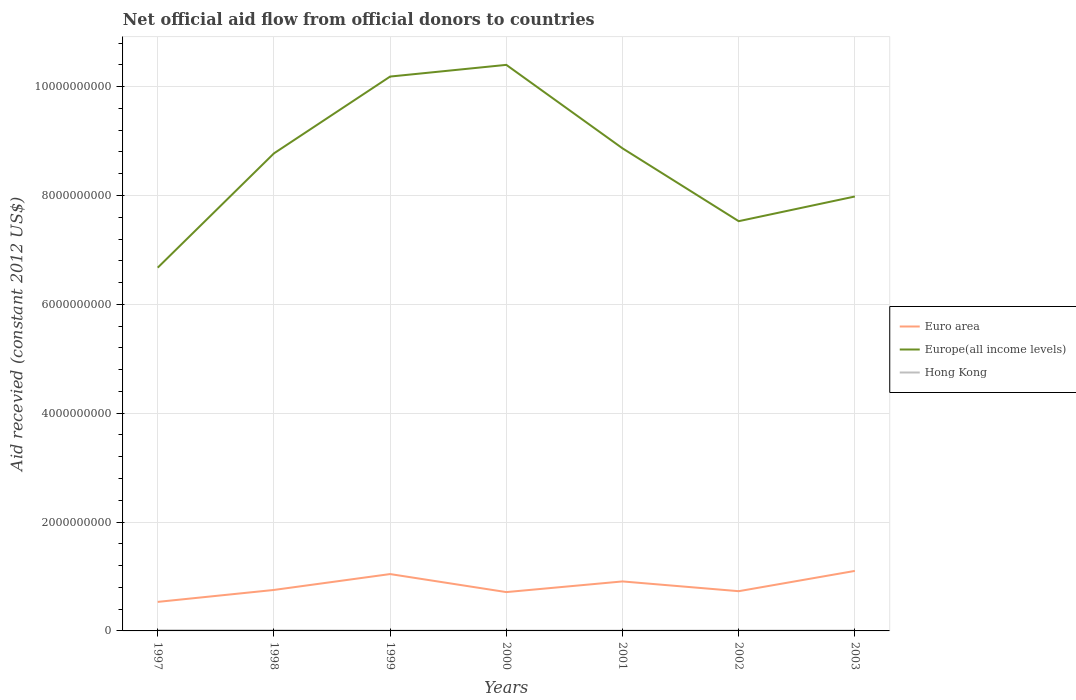How many different coloured lines are there?
Provide a short and direct response. 3. Across all years, what is the maximum total aid received in Europe(all income levels)?
Ensure brevity in your answer.  6.67e+09. In which year was the total aid received in Euro area maximum?
Offer a terse response. 1997. What is the total total aid received in Euro area in the graph?
Your answer should be compact. -1.57e+08. What is the difference between the highest and the second highest total aid received in Europe(all income levels)?
Make the answer very short. 3.73e+09. Is the total aid received in Europe(all income levels) strictly greater than the total aid received in Hong Kong over the years?
Your response must be concise. No. How many lines are there?
Provide a short and direct response. 3. How many years are there in the graph?
Provide a short and direct response. 7. Does the graph contain any zero values?
Keep it short and to the point. No. Does the graph contain grids?
Your answer should be compact. Yes. Where does the legend appear in the graph?
Offer a terse response. Center right. What is the title of the graph?
Give a very brief answer. Net official aid flow from official donors to countries. Does "Switzerland" appear as one of the legend labels in the graph?
Ensure brevity in your answer.  No. What is the label or title of the X-axis?
Your answer should be very brief. Years. What is the label or title of the Y-axis?
Provide a short and direct response. Aid recevied (constant 2012 US$). What is the Aid recevied (constant 2012 US$) of Euro area in 1997?
Your response must be concise. 5.33e+08. What is the Aid recevied (constant 2012 US$) of Europe(all income levels) in 1997?
Your response must be concise. 6.67e+09. What is the Aid recevied (constant 2012 US$) in Hong Kong in 1997?
Offer a very short reply. 1.18e+07. What is the Aid recevied (constant 2012 US$) of Euro area in 1998?
Keep it short and to the point. 7.53e+08. What is the Aid recevied (constant 2012 US$) of Europe(all income levels) in 1998?
Offer a very short reply. 8.77e+09. What is the Aid recevied (constant 2012 US$) in Hong Kong in 1998?
Keep it short and to the point. 9.64e+06. What is the Aid recevied (constant 2012 US$) in Euro area in 1999?
Your answer should be compact. 1.04e+09. What is the Aid recevied (constant 2012 US$) of Europe(all income levels) in 1999?
Your answer should be compact. 1.02e+1. What is the Aid recevied (constant 2012 US$) of Hong Kong in 1999?
Your answer should be compact. 4.73e+06. What is the Aid recevied (constant 2012 US$) of Euro area in 2000?
Provide a short and direct response. 7.13e+08. What is the Aid recevied (constant 2012 US$) of Europe(all income levels) in 2000?
Make the answer very short. 1.04e+1. What is the Aid recevied (constant 2012 US$) of Hong Kong in 2000?
Keep it short and to the point. 5.83e+06. What is the Aid recevied (constant 2012 US$) in Euro area in 2001?
Your answer should be very brief. 9.09e+08. What is the Aid recevied (constant 2012 US$) in Europe(all income levels) in 2001?
Your response must be concise. 8.87e+09. What is the Aid recevied (constant 2012 US$) in Hong Kong in 2001?
Provide a short and direct response. 5.12e+06. What is the Aid recevied (constant 2012 US$) in Euro area in 2002?
Keep it short and to the point. 7.30e+08. What is the Aid recevied (constant 2012 US$) in Europe(all income levels) in 2002?
Ensure brevity in your answer.  7.53e+09. What is the Aid recevied (constant 2012 US$) of Hong Kong in 2002?
Give a very brief answer. 5.92e+06. What is the Aid recevied (constant 2012 US$) in Euro area in 2003?
Your response must be concise. 1.10e+09. What is the Aid recevied (constant 2012 US$) in Europe(all income levels) in 2003?
Provide a succinct answer. 7.98e+09. What is the Aid recevied (constant 2012 US$) in Hong Kong in 2003?
Provide a short and direct response. 6.99e+06. Across all years, what is the maximum Aid recevied (constant 2012 US$) in Euro area?
Keep it short and to the point. 1.10e+09. Across all years, what is the maximum Aid recevied (constant 2012 US$) in Europe(all income levels)?
Your response must be concise. 1.04e+1. Across all years, what is the maximum Aid recevied (constant 2012 US$) of Hong Kong?
Make the answer very short. 1.18e+07. Across all years, what is the minimum Aid recevied (constant 2012 US$) of Euro area?
Your answer should be very brief. 5.33e+08. Across all years, what is the minimum Aid recevied (constant 2012 US$) of Europe(all income levels)?
Your response must be concise. 6.67e+09. Across all years, what is the minimum Aid recevied (constant 2012 US$) in Hong Kong?
Make the answer very short. 4.73e+06. What is the total Aid recevied (constant 2012 US$) of Euro area in the graph?
Ensure brevity in your answer.  5.79e+09. What is the total Aid recevied (constant 2012 US$) of Europe(all income levels) in the graph?
Give a very brief answer. 6.04e+1. What is the total Aid recevied (constant 2012 US$) in Hong Kong in the graph?
Offer a terse response. 5.00e+07. What is the difference between the Aid recevied (constant 2012 US$) in Euro area in 1997 and that in 1998?
Your answer should be compact. -2.19e+08. What is the difference between the Aid recevied (constant 2012 US$) of Europe(all income levels) in 1997 and that in 1998?
Make the answer very short. -2.10e+09. What is the difference between the Aid recevied (constant 2012 US$) in Hong Kong in 1997 and that in 1998?
Make the answer very short. 2.16e+06. What is the difference between the Aid recevied (constant 2012 US$) of Euro area in 1997 and that in 1999?
Your answer should be compact. -5.11e+08. What is the difference between the Aid recevied (constant 2012 US$) of Europe(all income levels) in 1997 and that in 1999?
Offer a very short reply. -3.51e+09. What is the difference between the Aid recevied (constant 2012 US$) of Hong Kong in 1997 and that in 1999?
Give a very brief answer. 7.07e+06. What is the difference between the Aid recevied (constant 2012 US$) of Euro area in 1997 and that in 2000?
Give a very brief answer. -1.80e+08. What is the difference between the Aid recevied (constant 2012 US$) of Europe(all income levels) in 1997 and that in 2000?
Your answer should be compact. -3.73e+09. What is the difference between the Aid recevied (constant 2012 US$) in Hong Kong in 1997 and that in 2000?
Keep it short and to the point. 5.97e+06. What is the difference between the Aid recevied (constant 2012 US$) in Euro area in 1997 and that in 2001?
Your response must be concise. -3.76e+08. What is the difference between the Aid recevied (constant 2012 US$) in Europe(all income levels) in 1997 and that in 2001?
Your answer should be compact. -2.19e+09. What is the difference between the Aid recevied (constant 2012 US$) in Hong Kong in 1997 and that in 2001?
Your answer should be compact. 6.68e+06. What is the difference between the Aid recevied (constant 2012 US$) in Euro area in 1997 and that in 2002?
Offer a very short reply. -1.97e+08. What is the difference between the Aid recevied (constant 2012 US$) of Europe(all income levels) in 1997 and that in 2002?
Ensure brevity in your answer.  -8.54e+08. What is the difference between the Aid recevied (constant 2012 US$) of Hong Kong in 1997 and that in 2002?
Ensure brevity in your answer.  5.88e+06. What is the difference between the Aid recevied (constant 2012 US$) in Euro area in 1997 and that in 2003?
Ensure brevity in your answer.  -5.69e+08. What is the difference between the Aid recevied (constant 2012 US$) of Europe(all income levels) in 1997 and that in 2003?
Give a very brief answer. -1.31e+09. What is the difference between the Aid recevied (constant 2012 US$) in Hong Kong in 1997 and that in 2003?
Provide a succinct answer. 4.81e+06. What is the difference between the Aid recevied (constant 2012 US$) in Euro area in 1998 and that in 1999?
Make the answer very short. -2.92e+08. What is the difference between the Aid recevied (constant 2012 US$) of Europe(all income levels) in 1998 and that in 1999?
Your answer should be compact. -1.41e+09. What is the difference between the Aid recevied (constant 2012 US$) of Hong Kong in 1998 and that in 1999?
Your answer should be very brief. 4.91e+06. What is the difference between the Aid recevied (constant 2012 US$) in Euro area in 1998 and that in 2000?
Keep it short and to the point. 3.93e+07. What is the difference between the Aid recevied (constant 2012 US$) in Europe(all income levels) in 1998 and that in 2000?
Give a very brief answer. -1.63e+09. What is the difference between the Aid recevied (constant 2012 US$) in Hong Kong in 1998 and that in 2000?
Offer a terse response. 3.81e+06. What is the difference between the Aid recevied (constant 2012 US$) in Euro area in 1998 and that in 2001?
Ensure brevity in your answer.  -1.57e+08. What is the difference between the Aid recevied (constant 2012 US$) in Europe(all income levels) in 1998 and that in 2001?
Ensure brevity in your answer.  -9.31e+07. What is the difference between the Aid recevied (constant 2012 US$) of Hong Kong in 1998 and that in 2001?
Offer a terse response. 4.52e+06. What is the difference between the Aid recevied (constant 2012 US$) of Euro area in 1998 and that in 2002?
Give a very brief answer. 2.28e+07. What is the difference between the Aid recevied (constant 2012 US$) of Europe(all income levels) in 1998 and that in 2002?
Keep it short and to the point. 1.25e+09. What is the difference between the Aid recevied (constant 2012 US$) in Hong Kong in 1998 and that in 2002?
Offer a very short reply. 3.72e+06. What is the difference between the Aid recevied (constant 2012 US$) of Euro area in 1998 and that in 2003?
Ensure brevity in your answer.  -3.50e+08. What is the difference between the Aid recevied (constant 2012 US$) of Europe(all income levels) in 1998 and that in 2003?
Give a very brief answer. 7.92e+08. What is the difference between the Aid recevied (constant 2012 US$) of Hong Kong in 1998 and that in 2003?
Make the answer very short. 2.65e+06. What is the difference between the Aid recevied (constant 2012 US$) of Euro area in 1999 and that in 2000?
Your answer should be compact. 3.31e+08. What is the difference between the Aid recevied (constant 2012 US$) of Europe(all income levels) in 1999 and that in 2000?
Your answer should be very brief. -2.15e+08. What is the difference between the Aid recevied (constant 2012 US$) in Hong Kong in 1999 and that in 2000?
Keep it short and to the point. -1.10e+06. What is the difference between the Aid recevied (constant 2012 US$) of Euro area in 1999 and that in 2001?
Provide a succinct answer. 1.35e+08. What is the difference between the Aid recevied (constant 2012 US$) of Europe(all income levels) in 1999 and that in 2001?
Offer a very short reply. 1.32e+09. What is the difference between the Aid recevied (constant 2012 US$) of Hong Kong in 1999 and that in 2001?
Make the answer very short. -3.90e+05. What is the difference between the Aid recevied (constant 2012 US$) in Euro area in 1999 and that in 2002?
Make the answer very short. 3.15e+08. What is the difference between the Aid recevied (constant 2012 US$) of Europe(all income levels) in 1999 and that in 2002?
Your response must be concise. 2.66e+09. What is the difference between the Aid recevied (constant 2012 US$) of Hong Kong in 1999 and that in 2002?
Give a very brief answer. -1.19e+06. What is the difference between the Aid recevied (constant 2012 US$) in Euro area in 1999 and that in 2003?
Ensure brevity in your answer.  -5.82e+07. What is the difference between the Aid recevied (constant 2012 US$) in Europe(all income levels) in 1999 and that in 2003?
Your answer should be very brief. 2.20e+09. What is the difference between the Aid recevied (constant 2012 US$) in Hong Kong in 1999 and that in 2003?
Your response must be concise. -2.26e+06. What is the difference between the Aid recevied (constant 2012 US$) in Euro area in 2000 and that in 2001?
Provide a short and direct response. -1.96e+08. What is the difference between the Aid recevied (constant 2012 US$) of Europe(all income levels) in 2000 and that in 2001?
Offer a terse response. 1.53e+09. What is the difference between the Aid recevied (constant 2012 US$) of Hong Kong in 2000 and that in 2001?
Provide a short and direct response. 7.10e+05. What is the difference between the Aid recevied (constant 2012 US$) in Euro area in 2000 and that in 2002?
Offer a very short reply. -1.65e+07. What is the difference between the Aid recevied (constant 2012 US$) of Europe(all income levels) in 2000 and that in 2002?
Give a very brief answer. 2.87e+09. What is the difference between the Aid recevied (constant 2012 US$) of Euro area in 2000 and that in 2003?
Ensure brevity in your answer.  -3.89e+08. What is the difference between the Aid recevied (constant 2012 US$) in Europe(all income levels) in 2000 and that in 2003?
Ensure brevity in your answer.  2.42e+09. What is the difference between the Aid recevied (constant 2012 US$) of Hong Kong in 2000 and that in 2003?
Your answer should be very brief. -1.16e+06. What is the difference between the Aid recevied (constant 2012 US$) of Euro area in 2001 and that in 2002?
Make the answer very short. 1.79e+08. What is the difference between the Aid recevied (constant 2012 US$) in Europe(all income levels) in 2001 and that in 2002?
Ensure brevity in your answer.  1.34e+09. What is the difference between the Aid recevied (constant 2012 US$) in Hong Kong in 2001 and that in 2002?
Provide a succinct answer. -8.00e+05. What is the difference between the Aid recevied (constant 2012 US$) in Euro area in 2001 and that in 2003?
Make the answer very short. -1.93e+08. What is the difference between the Aid recevied (constant 2012 US$) of Europe(all income levels) in 2001 and that in 2003?
Provide a short and direct response. 8.85e+08. What is the difference between the Aid recevied (constant 2012 US$) of Hong Kong in 2001 and that in 2003?
Provide a succinct answer. -1.87e+06. What is the difference between the Aid recevied (constant 2012 US$) in Euro area in 2002 and that in 2003?
Your answer should be compact. -3.73e+08. What is the difference between the Aid recevied (constant 2012 US$) in Europe(all income levels) in 2002 and that in 2003?
Keep it short and to the point. -4.54e+08. What is the difference between the Aid recevied (constant 2012 US$) of Hong Kong in 2002 and that in 2003?
Make the answer very short. -1.07e+06. What is the difference between the Aid recevied (constant 2012 US$) of Euro area in 1997 and the Aid recevied (constant 2012 US$) of Europe(all income levels) in 1998?
Ensure brevity in your answer.  -8.24e+09. What is the difference between the Aid recevied (constant 2012 US$) in Euro area in 1997 and the Aid recevied (constant 2012 US$) in Hong Kong in 1998?
Offer a very short reply. 5.24e+08. What is the difference between the Aid recevied (constant 2012 US$) of Europe(all income levels) in 1997 and the Aid recevied (constant 2012 US$) of Hong Kong in 1998?
Offer a terse response. 6.66e+09. What is the difference between the Aid recevied (constant 2012 US$) of Euro area in 1997 and the Aid recevied (constant 2012 US$) of Europe(all income levels) in 1999?
Keep it short and to the point. -9.65e+09. What is the difference between the Aid recevied (constant 2012 US$) in Euro area in 1997 and the Aid recevied (constant 2012 US$) in Hong Kong in 1999?
Make the answer very short. 5.29e+08. What is the difference between the Aid recevied (constant 2012 US$) in Europe(all income levels) in 1997 and the Aid recevied (constant 2012 US$) in Hong Kong in 1999?
Provide a short and direct response. 6.67e+09. What is the difference between the Aid recevied (constant 2012 US$) in Euro area in 1997 and the Aid recevied (constant 2012 US$) in Europe(all income levels) in 2000?
Give a very brief answer. -9.87e+09. What is the difference between the Aid recevied (constant 2012 US$) in Euro area in 1997 and the Aid recevied (constant 2012 US$) in Hong Kong in 2000?
Your response must be concise. 5.28e+08. What is the difference between the Aid recevied (constant 2012 US$) of Europe(all income levels) in 1997 and the Aid recevied (constant 2012 US$) of Hong Kong in 2000?
Ensure brevity in your answer.  6.67e+09. What is the difference between the Aid recevied (constant 2012 US$) of Euro area in 1997 and the Aid recevied (constant 2012 US$) of Europe(all income levels) in 2001?
Keep it short and to the point. -8.33e+09. What is the difference between the Aid recevied (constant 2012 US$) in Euro area in 1997 and the Aid recevied (constant 2012 US$) in Hong Kong in 2001?
Ensure brevity in your answer.  5.28e+08. What is the difference between the Aid recevied (constant 2012 US$) of Europe(all income levels) in 1997 and the Aid recevied (constant 2012 US$) of Hong Kong in 2001?
Your response must be concise. 6.67e+09. What is the difference between the Aid recevied (constant 2012 US$) in Euro area in 1997 and the Aid recevied (constant 2012 US$) in Europe(all income levels) in 2002?
Ensure brevity in your answer.  -7.00e+09. What is the difference between the Aid recevied (constant 2012 US$) of Euro area in 1997 and the Aid recevied (constant 2012 US$) of Hong Kong in 2002?
Provide a succinct answer. 5.27e+08. What is the difference between the Aid recevied (constant 2012 US$) in Europe(all income levels) in 1997 and the Aid recevied (constant 2012 US$) in Hong Kong in 2002?
Your answer should be very brief. 6.67e+09. What is the difference between the Aid recevied (constant 2012 US$) of Euro area in 1997 and the Aid recevied (constant 2012 US$) of Europe(all income levels) in 2003?
Provide a short and direct response. -7.45e+09. What is the difference between the Aid recevied (constant 2012 US$) of Euro area in 1997 and the Aid recevied (constant 2012 US$) of Hong Kong in 2003?
Your response must be concise. 5.26e+08. What is the difference between the Aid recevied (constant 2012 US$) in Europe(all income levels) in 1997 and the Aid recevied (constant 2012 US$) in Hong Kong in 2003?
Make the answer very short. 6.67e+09. What is the difference between the Aid recevied (constant 2012 US$) of Euro area in 1998 and the Aid recevied (constant 2012 US$) of Europe(all income levels) in 1999?
Your answer should be compact. -9.43e+09. What is the difference between the Aid recevied (constant 2012 US$) in Euro area in 1998 and the Aid recevied (constant 2012 US$) in Hong Kong in 1999?
Offer a very short reply. 7.48e+08. What is the difference between the Aid recevied (constant 2012 US$) of Europe(all income levels) in 1998 and the Aid recevied (constant 2012 US$) of Hong Kong in 1999?
Your response must be concise. 8.77e+09. What is the difference between the Aid recevied (constant 2012 US$) of Euro area in 1998 and the Aid recevied (constant 2012 US$) of Europe(all income levels) in 2000?
Provide a short and direct response. -9.65e+09. What is the difference between the Aid recevied (constant 2012 US$) of Euro area in 1998 and the Aid recevied (constant 2012 US$) of Hong Kong in 2000?
Your answer should be very brief. 7.47e+08. What is the difference between the Aid recevied (constant 2012 US$) of Europe(all income levels) in 1998 and the Aid recevied (constant 2012 US$) of Hong Kong in 2000?
Ensure brevity in your answer.  8.77e+09. What is the difference between the Aid recevied (constant 2012 US$) in Euro area in 1998 and the Aid recevied (constant 2012 US$) in Europe(all income levels) in 2001?
Your answer should be very brief. -8.11e+09. What is the difference between the Aid recevied (constant 2012 US$) in Euro area in 1998 and the Aid recevied (constant 2012 US$) in Hong Kong in 2001?
Your answer should be very brief. 7.48e+08. What is the difference between the Aid recevied (constant 2012 US$) of Europe(all income levels) in 1998 and the Aid recevied (constant 2012 US$) of Hong Kong in 2001?
Ensure brevity in your answer.  8.77e+09. What is the difference between the Aid recevied (constant 2012 US$) of Euro area in 1998 and the Aid recevied (constant 2012 US$) of Europe(all income levels) in 2002?
Offer a terse response. -6.78e+09. What is the difference between the Aid recevied (constant 2012 US$) in Euro area in 1998 and the Aid recevied (constant 2012 US$) in Hong Kong in 2002?
Make the answer very short. 7.47e+08. What is the difference between the Aid recevied (constant 2012 US$) in Europe(all income levels) in 1998 and the Aid recevied (constant 2012 US$) in Hong Kong in 2002?
Your answer should be compact. 8.77e+09. What is the difference between the Aid recevied (constant 2012 US$) in Euro area in 1998 and the Aid recevied (constant 2012 US$) in Europe(all income levels) in 2003?
Make the answer very short. -7.23e+09. What is the difference between the Aid recevied (constant 2012 US$) in Euro area in 1998 and the Aid recevied (constant 2012 US$) in Hong Kong in 2003?
Keep it short and to the point. 7.46e+08. What is the difference between the Aid recevied (constant 2012 US$) in Europe(all income levels) in 1998 and the Aid recevied (constant 2012 US$) in Hong Kong in 2003?
Your response must be concise. 8.77e+09. What is the difference between the Aid recevied (constant 2012 US$) in Euro area in 1999 and the Aid recevied (constant 2012 US$) in Europe(all income levels) in 2000?
Give a very brief answer. -9.36e+09. What is the difference between the Aid recevied (constant 2012 US$) in Euro area in 1999 and the Aid recevied (constant 2012 US$) in Hong Kong in 2000?
Make the answer very short. 1.04e+09. What is the difference between the Aid recevied (constant 2012 US$) of Europe(all income levels) in 1999 and the Aid recevied (constant 2012 US$) of Hong Kong in 2000?
Your answer should be compact. 1.02e+1. What is the difference between the Aid recevied (constant 2012 US$) of Euro area in 1999 and the Aid recevied (constant 2012 US$) of Europe(all income levels) in 2001?
Provide a short and direct response. -7.82e+09. What is the difference between the Aid recevied (constant 2012 US$) in Euro area in 1999 and the Aid recevied (constant 2012 US$) in Hong Kong in 2001?
Your response must be concise. 1.04e+09. What is the difference between the Aid recevied (constant 2012 US$) in Europe(all income levels) in 1999 and the Aid recevied (constant 2012 US$) in Hong Kong in 2001?
Ensure brevity in your answer.  1.02e+1. What is the difference between the Aid recevied (constant 2012 US$) in Euro area in 1999 and the Aid recevied (constant 2012 US$) in Europe(all income levels) in 2002?
Your answer should be compact. -6.48e+09. What is the difference between the Aid recevied (constant 2012 US$) of Euro area in 1999 and the Aid recevied (constant 2012 US$) of Hong Kong in 2002?
Provide a short and direct response. 1.04e+09. What is the difference between the Aid recevied (constant 2012 US$) of Europe(all income levels) in 1999 and the Aid recevied (constant 2012 US$) of Hong Kong in 2002?
Keep it short and to the point. 1.02e+1. What is the difference between the Aid recevied (constant 2012 US$) in Euro area in 1999 and the Aid recevied (constant 2012 US$) in Europe(all income levels) in 2003?
Your response must be concise. -6.94e+09. What is the difference between the Aid recevied (constant 2012 US$) of Euro area in 1999 and the Aid recevied (constant 2012 US$) of Hong Kong in 2003?
Provide a succinct answer. 1.04e+09. What is the difference between the Aid recevied (constant 2012 US$) in Europe(all income levels) in 1999 and the Aid recevied (constant 2012 US$) in Hong Kong in 2003?
Offer a very short reply. 1.02e+1. What is the difference between the Aid recevied (constant 2012 US$) in Euro area in 2000 and the Aid recevied (constant 2012 US$) in Europe(all income levels) in 2001?
Provide a succinct answer. -8.15e+09. What is the difference between the Aid recevied (constant 2012 US$) in Euro area in 2000 and the Aid recevied (constant 2012 US$) in Hong Kong in 2001?
Keep it short and to the point. 7.08e+08. What is the difference between the Aid recevied (constant 2012 US$) of Europe(all income levels) in 2000 and the Aid recevied (constant 2012 US$) of Hong Kong in 2001?
Give a very brief answer. 1.04e+1. What is the difference between the Aid recevied (constant 2012 US$) of Euro area in 2000 and the Aid recevied (constant 2012 US$) of Europe(all income levels) in 2002?
Ensure brevity in your answer.  -6.82e+09. What is the difference between the Aid recevied (constant 2012 US$) in Euro area in 2000 and the Aid recevied (constant 2012 US$) in Hong Kong in 2002?
Offer a very short reply. 7.08e+08. What is the difference between the Aid recevied (constant 2012 US$) of Europe(all income levels) in 2000 and the Aid recevied (constant 2012 US$) of Hong Kong in 2002?
Your answer should be compact. 1.04e+1. What is the difference between the Aid recevied (constant 2012 US$) in Euro area in 2000 and the Aid recevied (constant 2012 US$) in Europe(all income levels) in 2003?
Provide a short and direct response. -7.27e+09. What is the difference between the Aid recevied (constant 2012 US$) of Euro area in 2000 and the Aid recevied (constant 2012 US$) of Hong Kong in 2003?
Keep it short and to the point. 7.06e+08. What is the difference between the Aid recevied (constant 2012 US$) of Europe(all income levels) in 2000 and the Aid recevied (constant 2012 US$) of Hong Kong in 2003?
Offer a very short reply. 1.04e+1. What is the difference between the Aid recevied (constant 2012 US$) in Euro area in 2001 and the Aid recevied (constant 2012 US$) in Europe(all income levels) in 2002?
Provide a succinct answer. -6.62e+09. What is the difference between the Aid recevied (constant 2012 US$) in Euro area in 2001 and the Aid recevied (constant 2012 US$) in Hong Kong in 2002?
Give a very brief answer. 9.03e+08. What is the difference between the Aid recevied (constant 2012 US$) in Europe(all income levels) in 2001 and the Aid recevied (constant 2012 US$) in Hong Kong in 2002?
Ensure brevity in your answer.  8.86e+09. What is the difference between the Aid recevied (constant 2012 US$) in Euro area in 2001 and the Aid recevied (constant 2012 US$) in Europe(all income levels) in 2003?
Make the answer very short. -7.07e+09. What is the difference between the Aid recevied (constant 2012 US$) in Euro area in 2001 and the Aid recevied (constant 2012 US$) in Hong Kong in 2003?
Ensure brevity in your answer.  9.02e+08. What is the difference between the Aid recevied (constant 2012 US$) of Europe(all income levels) in 2001 and the Aid recevied (constant 2012 US$) of Hong Kong in 2003?
Keep it short and to the point. 8.86e+09. What is the difference between the Aid recevied (constant 2012 US$) of Euro area in 2002 and the Aid recevied (constant 2012 US$) of Europe(all income levels) in 2003?
Your answer should be compact. -7.25e+09. What is the difference between the Aid recevied (constant 2012 US$) in Euro area in 2002 and the Aid recevied (constant 2012 US$) in Hong Kong in 2003?
Ensure brevity in your answer.  7.23e+08. What is the difference between the Aid recevied (constant 2012 US$) in Europe(all income levels) in 2002 and the Aid recevied (constant 2012 US$) in Hong Kong in 2003?
Your answer should be very brief. 7.52e+09. What is the average Aid recevied (constant 2012 US$) of Euro area per year?
Your answer should be compact. 8.27e+08. What is the average Aid recevied (constant 2012 US$) of Europe(all income levels) per year?
Give a very brief answer. 8.63e+09. What is the average Aid recevied (constant 2012 US$) of Hong Kong per year?
Give a very brief answer. 7.15e+06. In the year 1997, what is the difference between the Aid recevied (constant 2012 US$) of Euro area and Aid recevied (constant 2012 US$) of Europe(all income levels)?
Keep it short and to the point. -6.14e+09. In the year 1997, what is the difference between the Aid recevied (constant 2012 US$) in Euro area and Aid recevied (constant 2012 US$) in Hong Kong?
Provide a succinct answer. 5.22e+08. In the year 1997, what is the difference between the Aid recevied (constant 2012 US$) in Europe(all income levels) and Aid recevied (constant 2012 US$) in Hong Kong?
Your answer should be compact. 6.66e+09. In the year 1998, what is the difference between the Aid recevied (constant 2012 US$) of Euro area and Aid recevied (constant 2012 US$) of Europe(all income levels)?
Keep it short and to the point. -8.02e+09. In the year 1998, what is the difference between the Aid recevied (constant 2012 US$) of Euro area and Aid recevied (constant 2012 US$) of Hong Kong?
Offer a very short reply. 7.43e+08. In the year 1998, what is the difference between the Aid recevied (constant 2012 US$) of Europe(all income levels) and Aid recevied (constant 2012 US$) of Hong Kong?
Ensure brevity in your answer.  8.76e+09. In the year 1999, what is the difference between the Aid recevied (constant 2012 US$) of Euro area and Aid recevied (constant 2012 US$) of Europe(all income levels)?
Make the answer very short. -9.14e+09. In the year 1999, what is the difference between the Aid recevied (constant 2012 US$) in Euro area and Aid recevied (constant 2012 US$) in Hong Kong?
Make the answer very short. 1.04e+09. In the year 1999, what is the difference between the Aid recevied (constant 2012 US$) in Europe(all income levels) and Aid recevied (constant 2012 US$) in Hong Kong?
Offer a very short reply. 1.02e+1. In the year 2000, what is the difference between the Aid recevied (constant 2012 US$) in Euro area and Aid recevied (constant 2012 US$) in Europe(all income levels)?
Give a very brief answer. -9.69e+09. In the year 2000, what is the difference between the Aid recevied (constant 2012 US$) in Euro area and Aid recevied (constant 2012 US$) in Hong Kong?
Keep it short and to the point. 7.08e+08. In the year 2000, what is the difference between the Aid recevied (constant 2012 US$) of Europe(all income levels) and Aid recevied (constant 2012 US$) of Hong Kong?
Offer a terse response. 1.04e+1. In the year 2001, what is the difference between the Aid recevied (constant 2012 US$) in Euro area and Aid recevied (constant 2012 US$) in Europe(all income levels)?
Offer a terse response. -7.96e+09. In the year 2001, what is the difference between the Aid recevied (constant 2012 US$) in Euro area and Aid recevied (constant 2012 US$) in Hong Kong?
Offer a very short reply. 9.04e+08. In the year 2001, what is the difference between the Aid recevied (constant 2012 US$) in Europe(all income levels) and Aid recevied (constant 2012 US$) in Hong Kong?
Provide a short and direct response. 8.86e+09. In the year 2002, what is the difference between the Aid recevied (constant 2012 US$) in Euro area and Aid recevied (constant 2012 US$) in Europe(all income levels)?
Your answer should be compact. -6.80e+09. In the year 2002, what is the difference between the Aid recevied (constant 2012 US$) of Euro area and Aid recevied (constant 2012 US$) of Hong Kong?
Keep it short and to the point. 7.24e+08. In the year 2002, what is the difference between the Aid recevied (constant 2012 US$) of Europe(all income levels) and Aid recevied (constant 2012 US$) of Hong Kong?
Offer a terse response. 7.52e+09. In the year 2003, what is the difference between the Aid recevied (constant 2012 US$) of Euro area and Aid recevied (constant 2012 US$) of Europe(all income levels)?
Keep it short and to the point. -6.88e+09. In the year 2003, what is the difference between the Aid recevied (constant 2012 US$) of Euro area and Aid recevied (constant 2012 US$) of Hong Kong?
Provide a short and direct response. 1.10e+09. In the year 2003, what is the difference between the Aid recevied (constant 2012 US$) in Europe(all income levels) and Aid recevied (constant 2012 US$) in Hong Kong?
Keep it short and to the point. 7.98e+09. What is the ratio of the Aid recevied (constant 2012 US$) of Euro area in 1997 to that in 1998?
Keep it short and to the point. 0.71. What is the ratio of the Aid recevied (constant 2012 US$) in Europe(all income levels) in 1997 to that in 1998?
Your answer should be very brief. 0.76. What is the ratio of the Aid recevied (constant 2012 US$) of Hong Kong in 1997 to that in 1998?
Provide a succinct answer. 1.22. What is the ratio of the Aid recevied (constant 2012 US$) in Euro area in 1997 to that in 1999?
Your answer should be very brief. 0.51. What is the ratio of the Aid recevied (constant 2012 US$) in Europe(all income levels) in 1997 to that in 1999?
Your answer should be very brief. 0.66. What is the ratio of the Aid recevied (constant 2012 US$) of Hong Kong in 1997 to that in 1999?
Your answer should be compact. 2.49. What is the ratio of the Aid recevied (constant 2012 US$) of Euro area in 1997 to that in 2000?
Make the answer very short. 0.75. What is the ratio of the Aid recevied (constant 2012 US$) of Europe(all income levels) in 1997 to that in 2000?
Offer a terse response. 0.64. What is the ratio of the Aid recevied (constant 2012 US$) in Hong Kong in 1997 to that in 2000?
Give a very brief answer. 2.02. What is the ratio of the Aid recevied (constant 2012 US$) in Euro area in 1997 to that in 2001?
Offer a very short reply. 0.59. What is the ratio of the Aid recevied (constant 2012 US$) of Europe(all income levels) in 1997 to that in 2001?
Provide a short and direct response. 0.75. What is the ratio of the Aid recevied (constant 2012 US$) of Hong Kong in 1997 to that in 2001?
Give a very brief answer. 2.3. What is the ratio of the Aid recevied (constant 2012 US$) of Euro area in 1997 to that in 2002?
Keep it short and to the point. 0.73. What is the ratio of the Aid recevied (constant 2012 US$) in Europe(all income levels) in 1997 to that in 2002?
Make the answer very short. 0.89. What is the ratio of the Aid recevied (constant 2012 US$) of Hong Kong in 1997 to that in 2002?
Keep it short and to the point. 1.99. What is the ratio of the Aid recevied (constant 2012 US$) of Euro area in 1997 to that in 2003?
Your answer should be compact. 0.48. What is the ratio of the Aid recevied (constant 2012 US$) of Europe(all income levels) in 1997 to that in 2003?
Make the answer very short. 0.84. What is the ratio of the Aid recevied (constant 2012 US$) in Hong Kong in 1997 to that in 2003?
Give a very brief answer. 1.69. What is the ratio of the Aid recevied (constant 2012 US$) of Euro area in 1998 to that in 1999?
Your response must be concise. 0.72. What is the ratio of the Aid recevied (constant 2012 US$) of Europe(all income levels) in 1998 to that in 1999?
Keep it short and to the point. 0.86. What is the ratio of the Aid recevied (constant 2012 US$) in Hong Kong in 1998 to that in 1999?
Give a very brief answer. 2.04. What is the ratio of the Aid recevied (constant 2012 US$) in Euro area in 1998 to that in 2000?
Your response must be concise. 1.06. What is the ratio of the Aid recevied (constant 2012 US$) of Europe(all income levels) in 1998 to that in 2000?
Provide a succinct answer. 0.84. What is the ratio of the Aid recevied (constant 2012 US$) in Hong Kong in 1998 to that in 2000?
Offer a very short reply. 1.65. What is the ratio of the Aid recevied (constant 2012 US$) of Euro area in 1998 to that in 2001?
Your answer should be compact. 0.83. What is the ratio of the Aid recevied (constant 2012 US$) of Europe(all income levels) in 1998 to that in 2001?
Provide a succinct answer. 0.99. What is the ratio of the Aid recevied (constant 2012 US$) in Hong Kong in 1998 to that in 2001?
Provide a short and direct response. 1.88. What is the ratio of the Aid recevied (constant 2012 US$) in Euro area in 1998 to that in 2002?
Your response must be concise. 1.03. What is the ratio of the Aid recevied (constant 2012 US$) of Europe(all income levels) in 1998 to that in 2002?
Your answer should be very brief. 1.17. What is the ratio of the Aid recevied (constant 2012 US$) of Hong Kong in 1998 to that in 2002?
Your answer should be very brief. 1.63. What is the ratio of the Aid recevied (constant 2012 US$) of Euro area in 1998 to that in 2003?
Offer a very short reply. 0.68. What is the ratio of the Aid recevied (constant 2012 US$) in Europe(all income levels) in 1998 to that in 2003?
Provide a succinct answer. 1.1. What is the ratio of the Aid recevied (constant 2012 US$) in Hong Kong in 1998 to that in 2003?
Provide a short and direct response. 1.38. What is the ratio of the Aid recevied (constant 2012 US$) of Euro area in 1999 to that in 2000?
Offer a very short reply. 1.46. What is the ratio of the Aid recevied (constant 2012 US$) of Europe(all income levels) in 1999 to that in 2000?
Offer a terse response. 0.98. What is the ratio of the Aid recevied (constant 2012 US$) of Hong Kong in 1999 to that in 2000?
Offer a terse response. 0.81. What is the ratio of the Aid recevied (constant 2012 US$) of Euro area in 1999 to that in 2001?
Your answer should be compact. 1.15. What is the ratio of the Aid recevied (constant 2012 US$) of Europe(all income levels) in 1999 to that in 2001?
Your response must be concise. 1.15. What is the ratio of the Aid recevied (constant 2012 US$) in Hong Kong in 1999 to that in 2001?
Your answer should be very brief. 0.92. What is the ratio of the Aid recevied (constant 2012 US$) in Euro area in 1999 to that in 2002?
Give a very brief answer. 1.43. What is the ratio of the Aid recevied (constant 2012 US$) in Europe(all income levels) in 1999 to that in 2002?
Your answer should be very brief. 1.35. What is the ratio of the Aid recevied (constant 2012 US$) in Hong Kong in 1999 to that in 2002?
Your response must be concise. 0.8. What is the ratio of the Aid recevied (constant 2012 US$) in Euro area in 1999 to that in 2003?
Offer a terse response. 0.95. What is the ratio of the Aid recevied (constant 2012 US$) in Europe(all income levels) in 1999 to that in 2003?
Your answer should be compact. 1.28. What is the ratio of the Aid recevied (constant 2012 US$) of Hong Kong in 1999 to that in 2003?
Give a very brief answer. 0.68. What is the ratio of the Aid recevied (constant 2012 US$) of Euro area in 2000 to that in 2001?
Give a very brief answer. 0.78. What is the ratio of the Aid recevied (constant 2012 US$) of Europe(all income levels) in 2000 to that in 2001?
Provide a short and direct response. 1.17. What is the ratio of the Aid recevied (constant 2012 US$) in Hong Kong in 2000 to that in 2001?
Offer a very short reply. 1.14. What is the ratio of the Aid recevied (constant 2012 US$) in Euro area in 2000 to that in 2002?
Keep it short and to the point. 0.98. What is the ratio of the Aid recevied (constant 2012 US$) in Europe(all income levels) in 2000 to that in 2002?
Keep it short and to the point. 1.38. What is the ratio of the Aid recevied (constant 2012 US$) in Euro area in 2000 to that in 2003?
Your answer should be very brief. 0.65. What is the ratio of the Aid recevied (constant 2012 US$) in Europe(all income levels) in 2000 to that in 2003?
Your answer should be very brief. 1.3. What is the ratio of the Aid recevied (constant 2012 US$) in Hong Kong in 2000 to that in 2003?
Make the answer very short. 0.83. What is the ratio of the Aid recevied (constant 2012 US$) in Euro area in 2001 to that in 2002?
Your answer should be compact. 1.25. What is the ratio of the Aid recevied (constant 2012 US$) in Europe(all income levels) in 2001 to that in 2002?
Give a very brief answer. 1.18. What is the ratio of the Aid recevied (constant 2012 US$) in Hong Kong in 2001 to that in 2002?
Offer a very short reply. 0.86. What is the ratio of the Aid recevied (constant 2012 US$) in Euro area in 2001 to that in 2003?
Make the answer very short. 0.82. What is the ratio of the Aid recevied (constant 2012 US$) of Europe(all income levels) in 2001 to that in 2003?
Provide a short and direct response. 1.11. What is the ratio of the Aid recevied (constant 2012 US$) of Hong Kong in 2001 to that in 2003?
Offer a very short reply. 0.73. What is the ratio of the Aid recevied (constant 2012 US$) of Euro area in 2002 to that in 2003?
Your response must be concise. 0.66. What is the ratio of the Aid recevied (constant 2012 US$) of Europe(all income levels) in 2002 to that in 2003?
Offer a terse response. 0.94. What is the ratio of the Aid recevied (constant 2012 US$) in Hong Kong in 2002 to that in 2003?
Provide a succinct answer. 0.85. What is the difference between the highest and the second highest Aid recevied (constant 2012 US$) in Euro area?
Give a very brief answer. 5.82e+07. What is the difference between the highest and the second highest Aid recevied (constant 2012 US$) in Europe(all income levels)?
Provide a short and direct response. 2.15e+08. What is the difference between the highest and the second highest Aid recevied (constant 2012 US$) of Hong Kong?
Make the answer very short. 2.16e+06. What is the difference between the highest and the lowest Aid recevied (constant 2012 US$) of Euro area?
Provide a short and direct response. 5.69e+08. What is the difference between the highest and the lowest Aid recevied (constant 2012 US$) of Europe(all income levels)?
Ensure brevity in your answer.  3.73e+09. What is the difference between the highest and the lowest Aid recevied (constant 2012 US$) of Hong Kong?
Ensure brevity in your answer.  7.07e+06. 